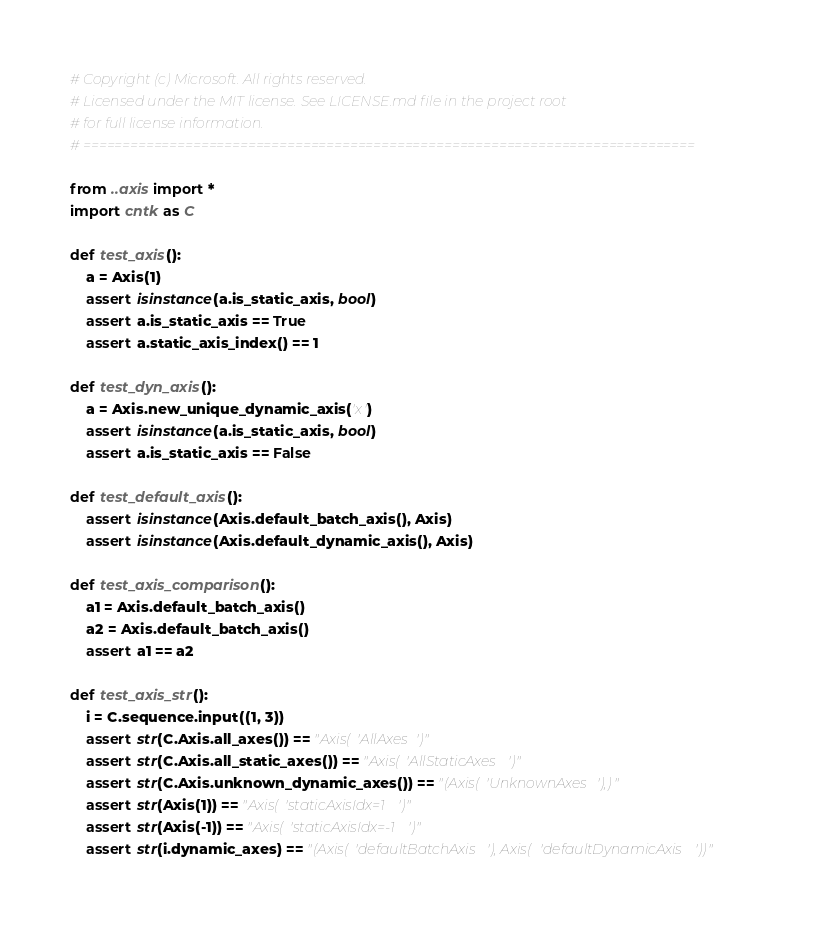Convert code to text. <code><loc_0><loc_0><loc_500><loc_500><_Python_># Copyright (c) Microsoft. All rights reserved.
# Licensed under the MIT license. See LICENSE.md file in the project root
# for full license information.
# ==============================================================================

from ..axis import *
import cntk as C

def test_axis():
    a = Axis(1)
    assert isinstance(a.is_static_axis, bool)
    assert a.is_static_axis == True
    assert a.static_axis_index() == 1

def test_dyn_axis():
    a = Axis.new_unique_dynamic_axis('x')
    assert isinstance(a.is_static_axis, bool)
    assert a.is_static_axis == False

def test_default_axis():
    assert isinstance(Axis.default_batch_axis(), Axis)
    assert isinstance(Axis.default_dynamic_axis(), Axis)

def test_axis_comparison():
    a1 = Axis.default_batch_axis()
    a2 = Axis.default_batch_axis()
    assert a1 == a2

def test_axis_str():
    i = C.sequence.input((1, 3))
    assert str(C.Axis.all_axes()) == "Axis('AllAxes')"
    assert str(C.Axis.all_static_axes()) == "Axis('AllStaticAxes')"
    assert str(C.Axis.unknown_dynamic_axes()) == "(Axis('UnknownAxes'),)"
    assert str(Axis(1)) == "Axis('staticAxisIdx=1')"
    assert str(Axis(-1)) == "Axis('staticAxisIdx=-1')"
    assert str(i.dynamic_axes) == "(Axis('defaultBatchAxis'), Axis('defaultDynamicAxis'))"
</code> 